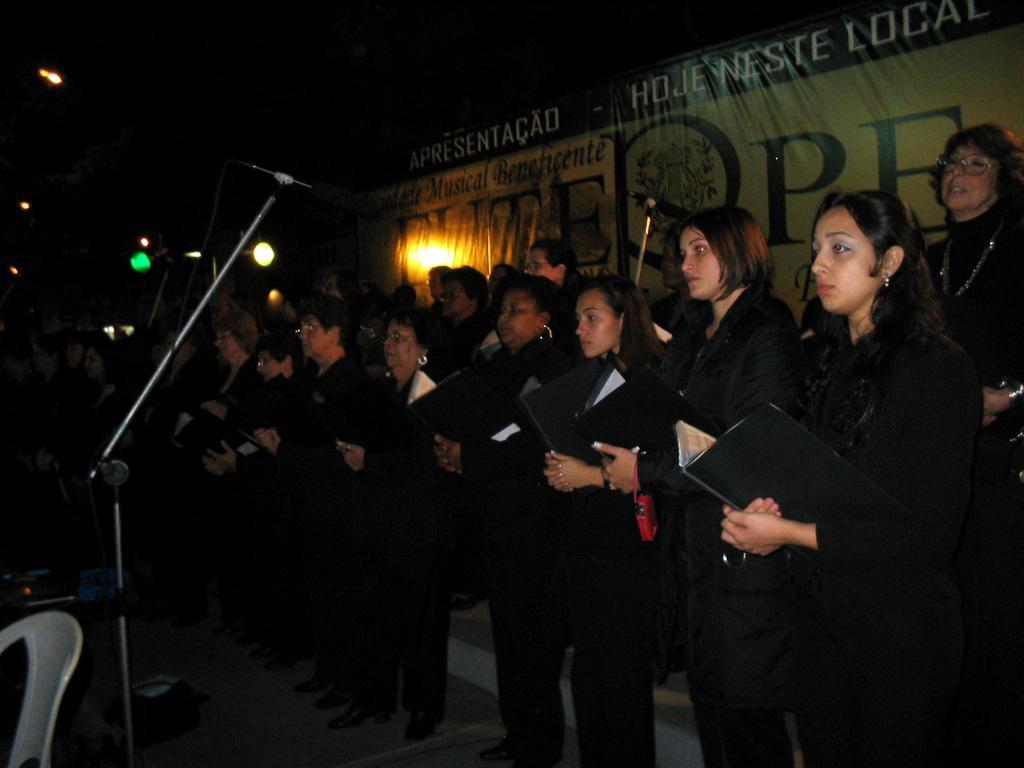Could you give a brief overview of what you see in this image? In the center of the image there are people standing holding files in their hands. In the background of the image there is a banner. There is a mic. To the left side of the image there is a chair. 